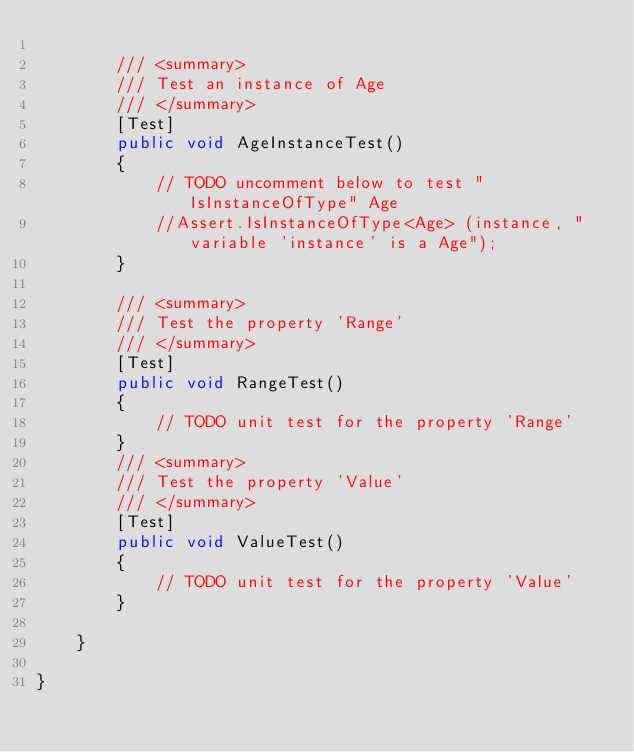Convert code to text. <code><loc_0><loc_0><loc_500><loc_500><_C#_>
        /// <summary>
        /// Test an instance of Age
        /// </summary>
        [Test]
        public void AgeInstanceTest()
        {
            // TODO uncomment below to test "IsInstanceOfType" Age
            //Assert.IsInstanceOfType<Age> (instance, "variable 'instance' is a Age");
        }

        /// <summary>
        /// Test the property 'Range'
        /// </summary>
        [Test]
        public void RangeTest()
        {
            // TODO unit test for the property 'Range'
        }
        /// <summary>
        /// Test the property 'Value'
        /// </summary>
        [Test]
        public void ValueTest()
        {
            // TODO unit test for the property 'Value'
        }

    }

}
</code> 